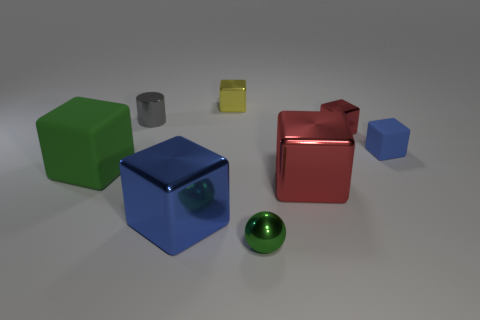Subtract all yellow metal cubes. How many cubes are left? 5 Subtract all blue cubes. How many cubes are left? 4 Subtract all yellow blocks. Subtract all cyan balls. How many blocks are left? 5 Add 2 big brown cubes. How many objects exist? 10 Subtract all cubes. How many objects are left? 2 Add 3 tiny gray shiny cylinders. How many tiny gray shiny cylinders are left? 4 Add 2 small green metal things. How many small green metal things exist? 3 Subtract 1 blue cubes. How many objects are left? 7 Subtract all large green shiny cylinders. Subtract all green blocks. How many objects are left? 7 